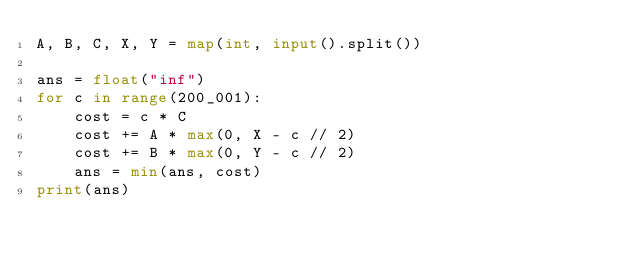<code> <loc_0><loc_0><loc_500><loc_500><_Python_>A, B, C, X, Y = map(int, input().split())

ans = float("inf")
for c in range(200_001):
    cost = c * C
    cost += A * max(0, X - c // 2)
    cost += B * max(0, Y - c // 2)
    ans = min(ans, cost)
print(ans)
</code> 